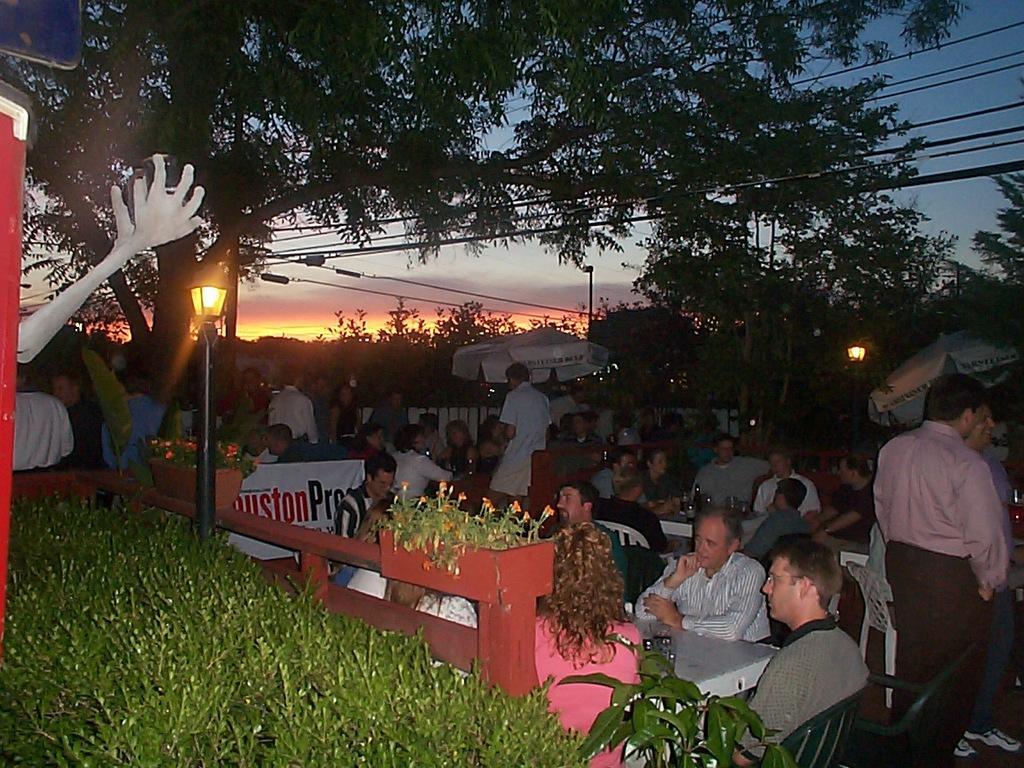Could you give a brief overview of what you see in this image? In this image there is the sky, there are trees, there is pole, there are wires, there are persons sitting on the chair, there are tables, there are objects on the table, there is a flower pot, there are plants, there are flowers, there is an umbrella, there is a street light, there are objects truncated towards the left of the image. 